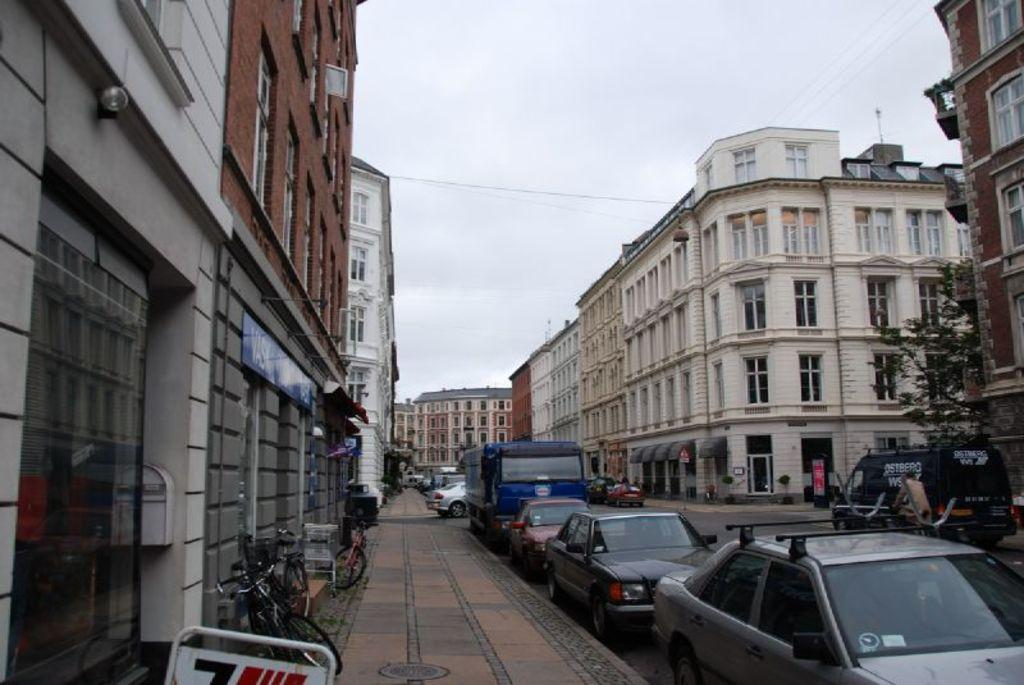What can be seen on the road in the image? There are vehicles on the road in the image. What type of animals can be seen in the image? Birds are visible in the image. What type of structures are present in the image? There are buildings in the image. What type of vegetation is present in the image? There is a tree in the image. What is visible in the background of the image? The sky is visible in the background of the image. Where is the scarecrow located in the image? There is no scarecrow present in the image. What type of flesh can be seen in the image? There is no flesh visible in the image. 